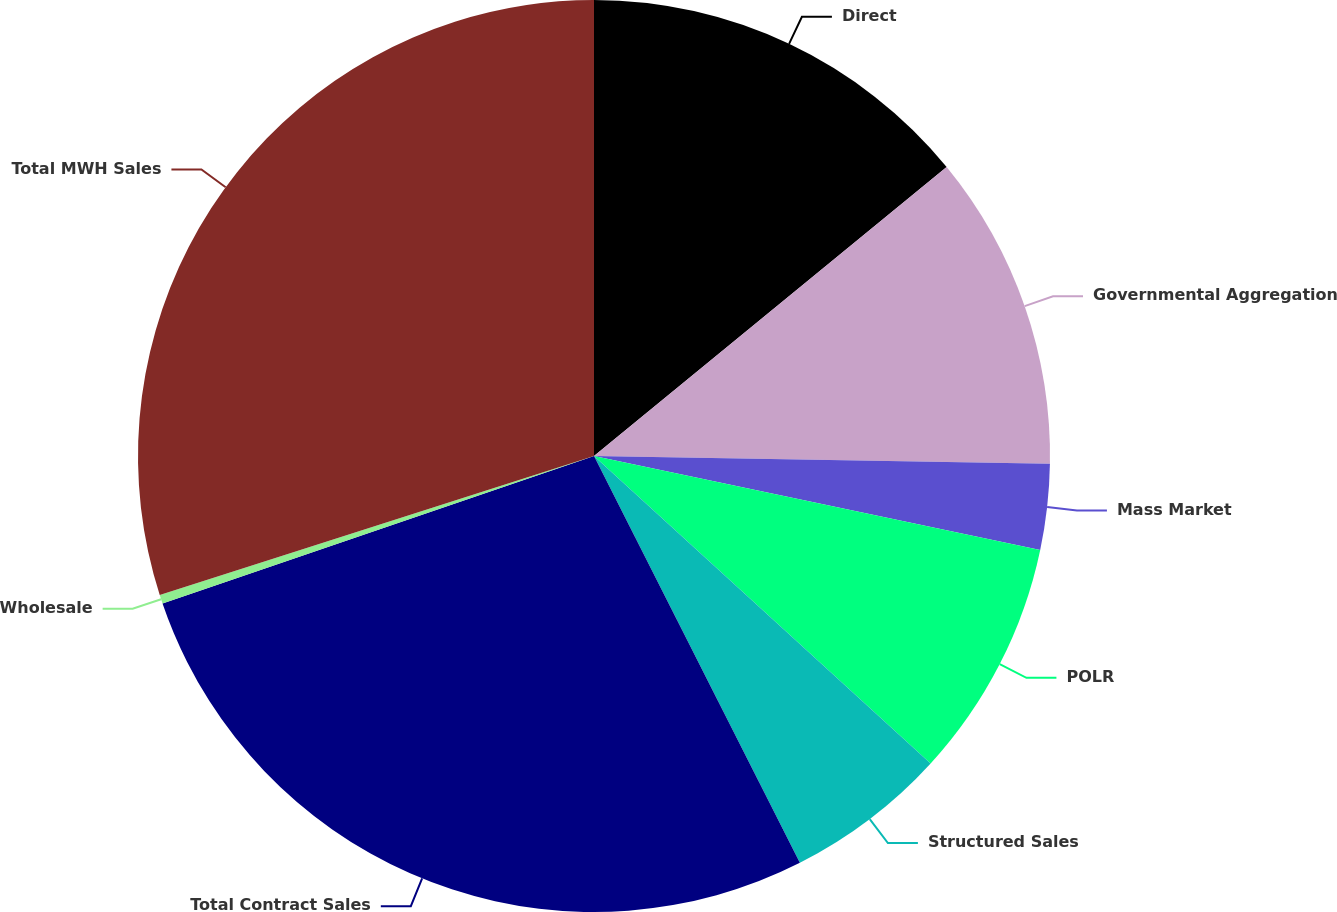<chart> <loc_0><loc_0><loc_500><loc_500><pie_chart><fcel>Direct<fcel>Governmental Aggregation<fcel>Mass Market<fcel>POLR<fcel>Structured Sales<fcel>Total Contract Sales<fcel>Wholesale<fcel>Total MWH Sales<nl><fcel>14.07%<fcel>11.2%<fcel>3.03%<fcel>8.48%<fcel>5.76%<fcel>27.21%<fcel>0.31%<fcel>29.93%<nl></chart> 